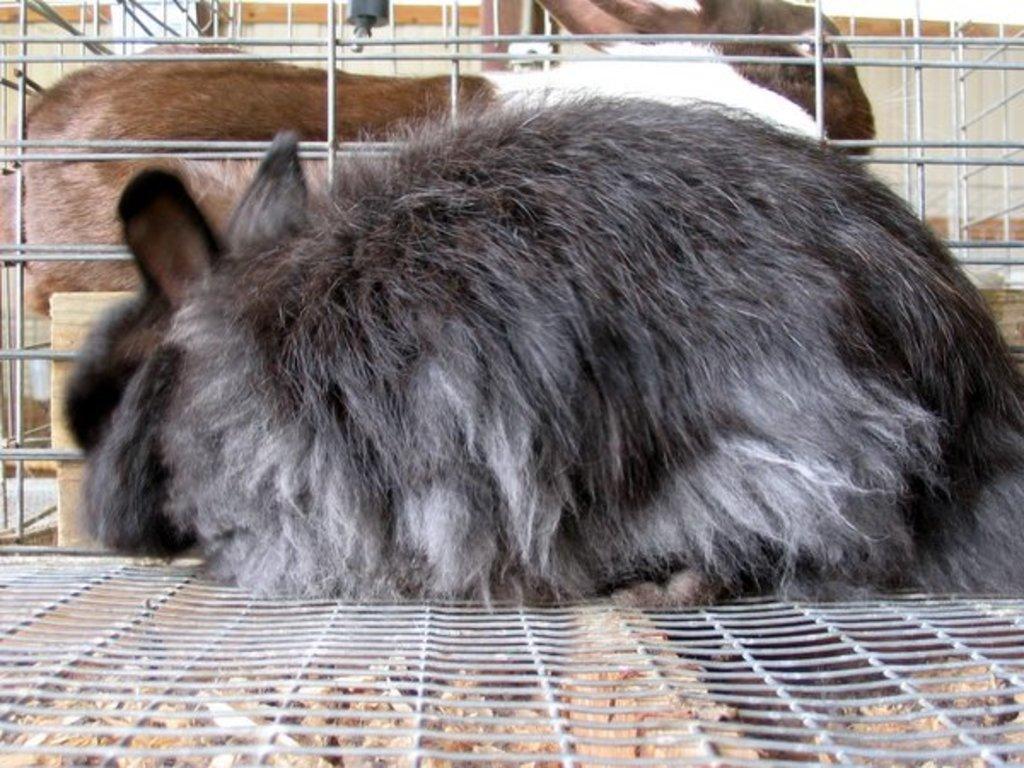Can you describe this image briefly? In this picture we can see some rabbits are in the cage. 